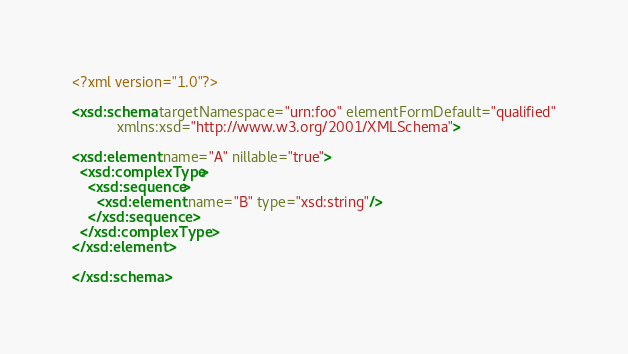<code> <loc_0><loc_0><loc_500><loc_500><_XML_><?xml version="1.0"?>

<xsd:schema targetNamespace="urn:foo" elementFormDefault="qualified"
           xmlns:xsd="http://www.w3.org/2001/XMLSchema">

<xsd:element name="A" nillable="true">
  <xsd:complexType>
    <xsd:sequence>
      <xsd:element name="B" type="xsd:string"/>
    </xsd:sequence>
  </xsd:complexType>
</xsd:element>

</xsd:schema>
</code> 